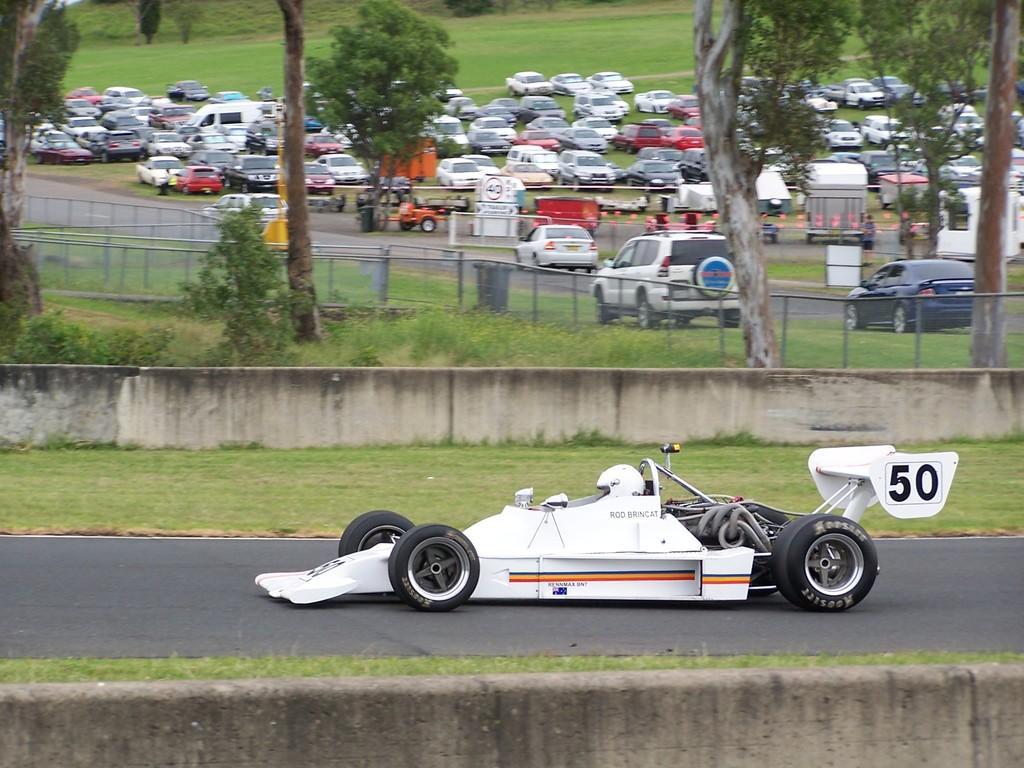Can you describe this image briefly? In this picture we can see a vehicle on the road and in the background we can see the wall, trees and a group of vehicles. 